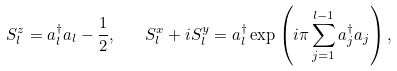<formula> <loc_0><loc_0><loc_500><loc_500>S _ { l } ^ { z } = a _ { l } ^ { \dagger } a _ { l } - \frac { 1 } { 2 } , \quad S _ { l } ^ { x } + i S _ { l } ^ { y } = a _ { l } ^ { \dagger } \exp \left ( i \pi \sum _ { j = 1 } ^ { l - 1 } a _ { j } ^ { \dagger } a _ { j } \right ) ,</formula> 